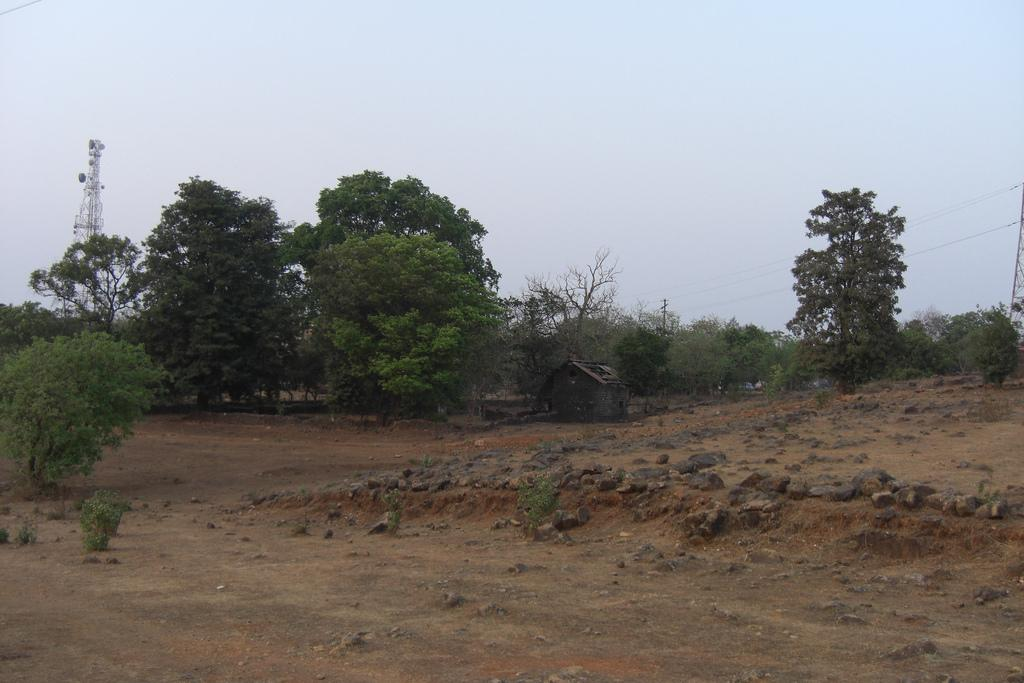What type of terrain is depicted in the image? The image contains a muddy surface with rocks. What can be seen in the distance in the image? There are trees visible in the distance. What structure is present in the background of the image? There is a tower in the background. What part of the natural environment is visible in the image? The sky is visible in the image. Where is the throne located in the image? There is no throne present in the image. What type of floor can be seen beneath the rocks in the image? The image does not show a floor beneath the rocks; it only shows a muddy surface. 